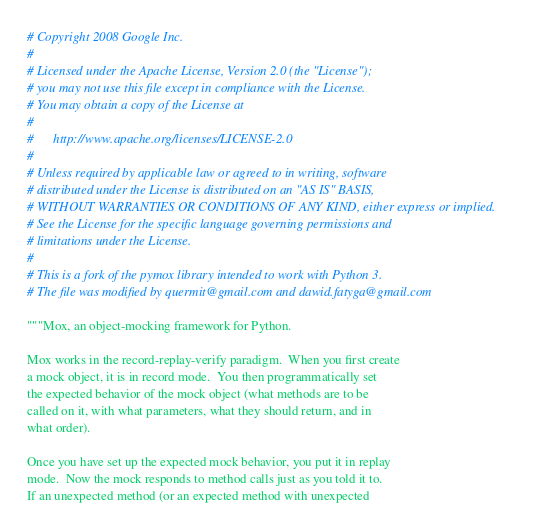<code> <loc_0><loc_0><loc_500><loc_500><_Python_># Copyright 2008 Google Inc.
#
# Licensed under the Apache License, Version 2.0 (the "License");
# you may not use this file except in compliance with the License.
# You may obtain a copy of the License at
#
#      http://www.apache.org/licenses/LICENSE-2.0
#
# Unless required by applicable law or agreed to in writing, software
# distributed under the License is distributed on an "AS IS" BASIS,
# WITHOUT WARRANTIES OR CONDITIONS OF ANY KIND, either express or implied.
# See the License for the specific language governing permissions and
# limitations under the License.
#
# This is a fork of the pymox library intended to work with Python 3.
# The file was modified by quermit@gmail.com and dawid.fatyga@gmail.com

"""Mox, an object-mocking framework for Python.

Mox works in the record-replay-verify paradigm.  When you first create
a mock object, it is in record mode.  You then programmatically set
the expected behavior of the mock object (what methods are to be
called on it, with what parameters, what they should return, and in
what order).

Once you have set up the expected mock behavior, you put it in replay
mode.  Now the mock responds to method calls just as you told it to.
If an unexpected method (or an expected method with unexpected</code> 